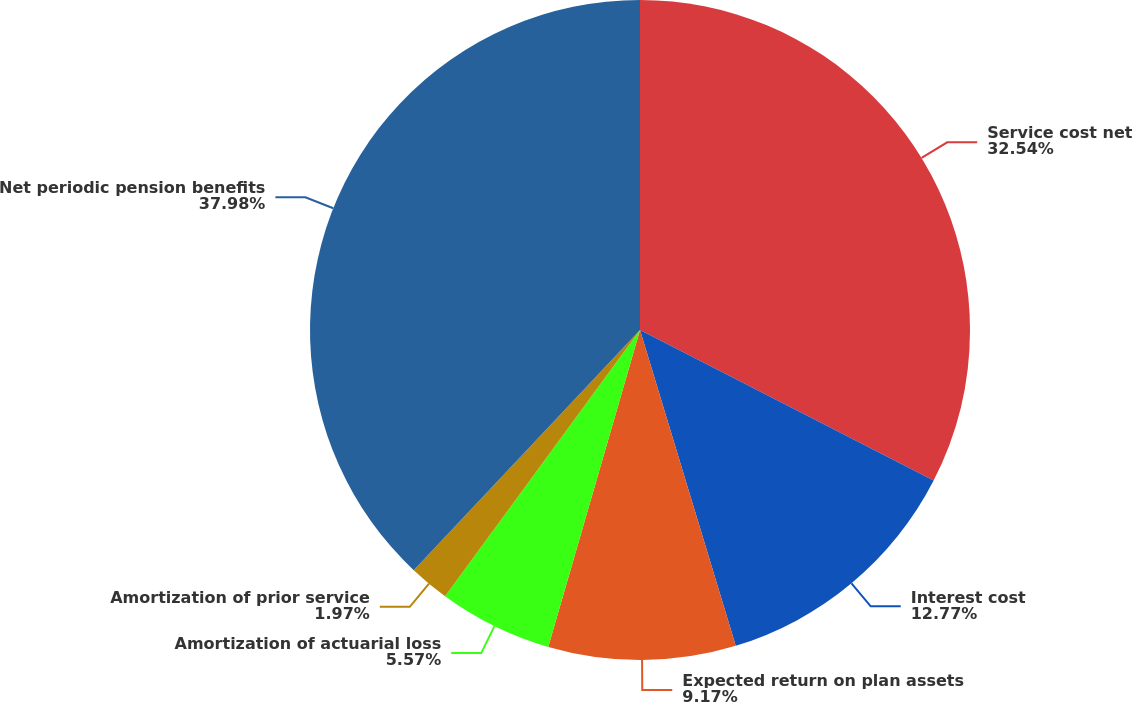Convert chart to OTSL. <chart><loc_0><loc_0><loc_500><loc_500><pie_chart><fcel>Service cost net<fcel>Interest cost<fcel>Expected return on plan assets<fcel>Amortization of actuarial loss<fcel>Amortization of prior service<fcel>Net periodic pension benefits<nl><fcel>32.54%<fcel>12.77%<fcel>9.17%<fcel>5.57%<fcel>1.97%<fcel>37.97%<nl></chart> 